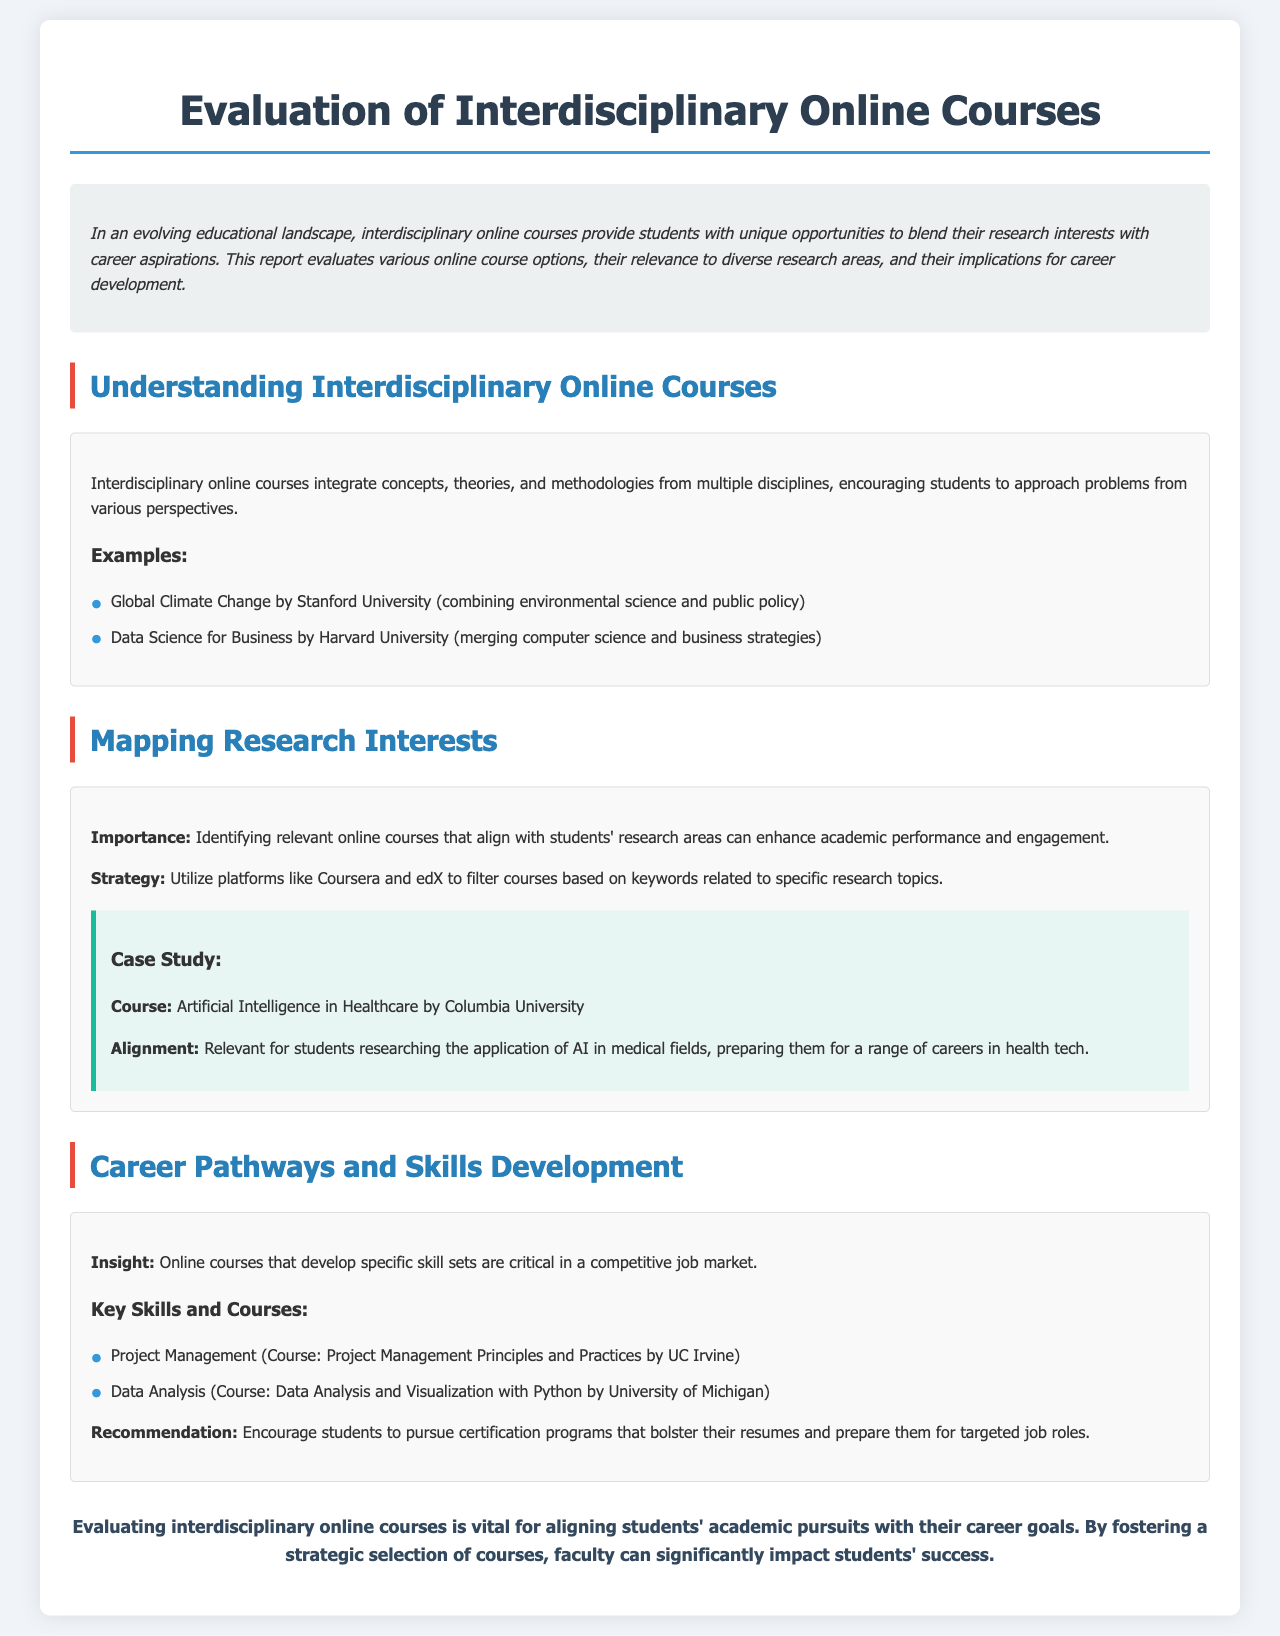What is the title of the report? The title of the report is stated at the top of the document.
Answer: Evaluation of Interdisciplinary Online Courses Which university offers the course "Global Climate Change"? The course is listed under examples of interdisciplinary online courses.
Answer: Stanford University What is one key skill mentioned that is critical in a competitive job market? The document specifies skills that are important for career development.
Answer: Project Management Which platform is recommended for filtering courses based on research topics? The report suggests using a platform for aligning courses with research interests.
Answer: Coursera and edX What type of courses does the report emphasize? The report clearly indicates the focus on a specific category of courses.
Answer: Interdisciplinary online courses What does the case study in the document relate to? The case study explains the relevance of a specific course to a field of study.
Answer: AI in Healthcare What is a recommended course for Data Analysis? This course is listed under the skills development section of the document.
Answer: Data Analysis and Visualization with Python What is the purpose of evaluating interdisciplinary online courses, according to the conclusion? The conclusion summarizes the overall purpose of the evaluation process.
Answer: Aligning academic pursuits with career goals 